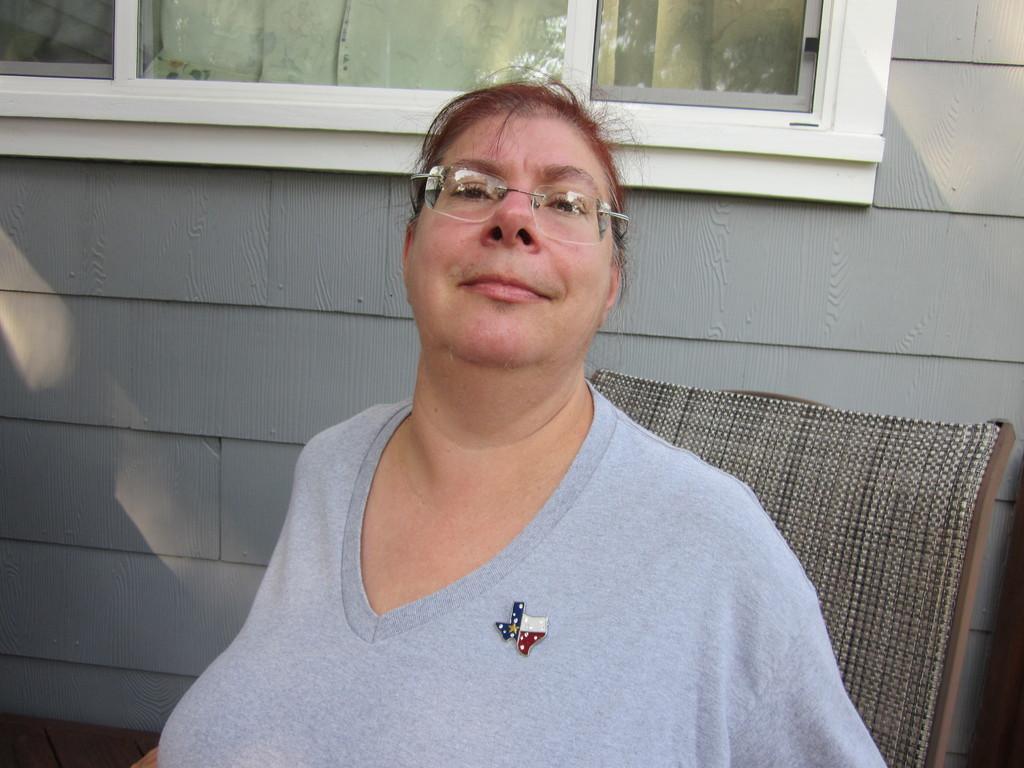In one or two sentences, can you explain what this image depicts? In this image in the front there is a woman sitting on chair and smiling. In the background there is a wall and there is a window. 